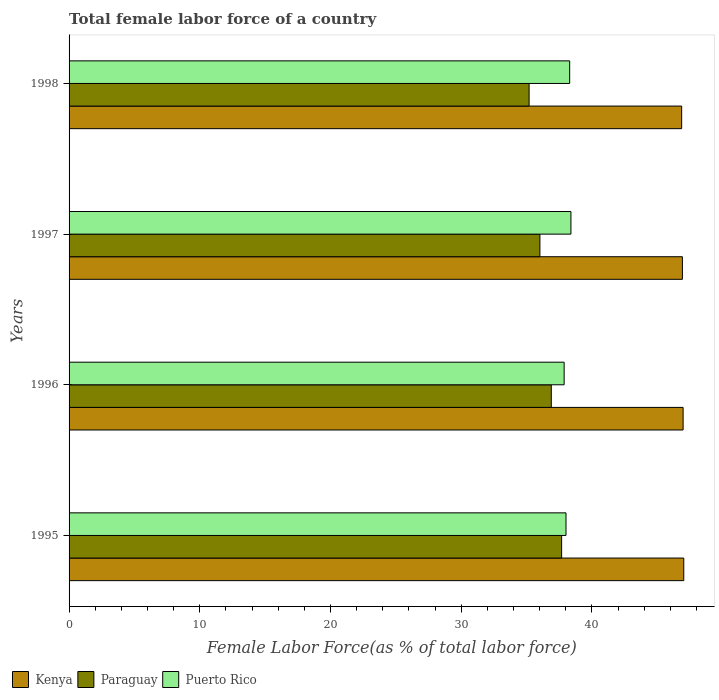Are the number of bars per tick equal to the number of legend labels?
Make the answer very short. Yes. Are the number of bars on each tick of the Y-axis equal?
Give a very brief answer. Yes. How many bars are there on the 2nd tick from the bottom?
Make the answer very short. 3. What is the percentage of female labor force in Kenya in 1996?
Your response must be concise. 46.97. Across all years, what is the maximum percentage of female labor force in Paraguay?
Ensure brevity in your answer.  37.68. Across all years, what is the minimum percentage of female labor force in Paraguay?
Your response must be concise. 35.19. In which year was the percentage of female labor force in Paraguay minimum?
Your answer should be compact. 1998. What is the total percentage of female labor force in Kenya in the graph?
Give a very brief answer. 187.78. What is the difference between the percentage of female labor force in Puerto Rico in 1995 and that in 1998?
Keep it short and to the point. -0.28. What is the difference between the percentage of female labor force in Kenya in 1996 and the percentage of female labor force in Paraguay in 1995?
Ensure brevity in your answer.  9.29. What is the average percentage of female labor force in Puerto Rico per year?
Offer a terse response. 38.14. In the year 1996, what is the difference between the percentage of female labor force in Kenya and percentage of female labor force in Paraguay?
Provide a short and direct response. 10.08. What is the ratio of the percentage of female labor force in Kenya in 1996 to that in 1998?
Make the answer very short. 1. Is the percentage of female labor force in Paraguay in 1995 less than that in 1996?
Ensure brevity in your answer.  No. What is the difference between the highest and the second highest percentage of female labor force in Paraguay?
Offer a terse response. 0.79. What is the difference between the highest and the lowest percentage of female labor force in Kenya?
Offer a terse response. 0.16. In how many years, is the percentage of female labor force in Paraguay greater than the average percentage of female labor force in Paraguay taken over all years?
Provide a short and direct response. 2. Is the sum of the percentage of female labor force in Kenya in 1995 and 1998 greater than the maximum percentage of female labor force in Paraguay across all years?
Make the answer very short. Yes. What does the 3rd bar from the top in 1997 represents?
Your answer should be compact. Kenya. What does the 2nd bar from the bottom in 1998 represents?
Keep it short and to the point. Paraguay. Are all the bars in the graph horizontal?
Provide a short and direct response. Yes. What is the difference between two consecutive major ticks on the X-axis?
Provide a short and direct response. 10. Does the graph contain any zero values?
Your response must be concise. No. Does the graph contain grids?
Provide a succinct answer. No. How many legend labels are there?
Make the answer very short. 3. What is the title of the graph?
Your response must be concise. Total female labor force of a country. What is the label or title of the X-axis?
Make the answer very short. Female Labor Force(as % of total labor force). What is the label or title of the Y-axis?
Your answer should be compact. Years. What is the Female Labor Force(as % of total labor force) of Kenya in 1995?
Make the answer very short. 47.02. What is the Female Labor Force(as % of total labor force) of Paraguay in 1995?
Make the answer very short. 37.68. What is the Female Labor Force(as % of total labor force) in Puerto Rico in 1995?
Give a very brief answer. 38.01. What is the Female Labor Force(as % of total labor force) of Kenya in 1996?
Your answer should be compact. 46.97. What is the Female Labor Force(as % of total labor force) of Paraguay in 1996?
Keep it short and to the point. 36.89. What is the Female Labor Force(as % of total labor force) in Puerto Rico in 1996?
Your answer should be very brief. 37.87. What is the Female Labor Force(as % of total labor force) in Kenya in 1997?
Offer a very short reply. 46.92. What is the Female Labor Force(as % of total labor force) in Paraguay in 1997?
Make the answer very short. 36.02. What is the Female Labor Force(as % of total labor force) in Puerto Rico in 1997?
Make the answer very short. 38.39. What is the Female Labor Force(as % of total labor force) in Kenya in 1998?
Give a very brief answer. 46.86. What is the Female Labor Force(as % of total labor force) in Paraguay in 1998?
Your answer should be very brief. 35.19. What is the Female Labor Force(as % of total labor force) in Puerto Rico in 1998?
Offer a very short reply. 38.3. Across all years, what is the maximum Female Labor Force(as % of total labor force) in Kenya?
Provide a short and direct response. 47.02. Across all years, what is the maximum Female Labor Force(as % of total labor force) in Paraguay?
Provide a succinct answer. 37.68. Across all years, what is the maximum Female Labor Force(as % of total labor force) of Puerto Rico?
Your answer should be compact. 38.39. Across all years, what is the minimum Female Labor Force(as % of total labor force) of Kenya?
Give a very brief answer. 46.86. Across all years, what is the minimum Female Labor Force(as % of total labor force) in Paraguay?
Offer a terse response. 35.19. Across all years, what is the minimum Female Labor Force(as % of total labor force) in Puerto Rico?
Ensure brevity in your answer.  37.87. What is the total Female Labor Force(as % of total labor force) in Kenya in the graph?
Give a very brief answer. 187.78. What is the total Female Labor Force(as % of total labor force) of Paraguay in the graph?
Provide a short and direct response. 145.78. What is the total Female Labor Force(as % of total labor force) in Puerto Rico in the graph?
Make the answer very short. 152.57. What is the difference between the Female Labor Force(as % of total labor force) in Kenya in 1995 and that in 1996?
Your answer should be compact. 0.05. What is the difference between the Female Labor Force(as % of total labor force) in Paraguay in 1995 and that in 1996?
Keep it short and to the point. 0.79. What is the difference between the Female Labor Force(as % of total labor force) of Puerto Rico in 1995 and that in 1996?
Provide a short and direct response. 0.14. What is the difference between the Female Labor Force(as % of total labor force) of Kenya in 1995 and that in 1997?
Provide a short and direct response. 0.1. What is the difference between the Female Labor Force(as % of total labor force) in Paraguay in 1995 and that in 1997?
Your response must be concise. 1.66. What is the difference between the Female Labor Force(as % of total labor force) in Puerto Rico in 1995 and that in 1997?
Provide a succinct answer. -0.38. What is the difference between the Female Labor Force(as % of total labor force) in Kenya in 1995 and that in 1998?
Provide a succinct answer. 0.16. What is the difference between the Female Labor Force(as % of total labor force) of Paraguay in 1995 and that in 1998?
Provide a succinct answer. 2.49. What is the difference between the Female Labor Force(as % of total labor force) of Puerto Rico in 1995 and that in 1998?
Make the answer very short. -0.28. What is the difference between the Female Labor Force(as % of total labor force) of Kenya in 1996 and that in 1997?
Offer a terse response. 0.05. What is the difference between the Female Labor Force(as % of total labor force) in Paraguay in 1996 and that in 1997?
Provide a succinct answer. 0.87. What is the difference between the Female Labor Force(as % of total labor force) of Puerto Rico in 1996 and that in 1997?
Give a very brief answer. -0.52. What is the difference between the Female Labor Force(as % of total labor force) in Kenya in 1996 and that in 1998?
Offer a terse response. 0.11. What is the difference between the Female Labor Force(as % of total labor force) of Paraguay in 1996 and that in 1998?
Your answer should be very brief. 1.7. What is the difference between the Female Labor Force(as % of total labor force) of Puerto Rico in 1996 and that in 1998?
Give a very brief answer. -0.42. What is the difference between the Female Labor Force(as % of total labor force) in Kenya in 1997 and that in 1998?
Offer a very short reply. 0.06. What is the difference between the Female Labor Force(as % of total labor force) in Paraguay in 1997 and that in 1998?
Give a very brief answer. 0.83. What is the difference between the Female Labor Force(as % of total labor force) in Puerto Rico in 1997 and that in 1998?
Offer a very short reply. 0.1. What is the difference between the Female Labor Force(as % of total labor force) in Kenya in 1995 and the Female Labor Force(as % of total labor force) in Paraguay in 1996?
Make the answer very short. 10.13. What is the difference between the Female Labor Force(as % of total labor force) in Kenya in 1995 and the Female Labor Force(as % of total labor force) in Puerto Rico in 1996?
Your response must be concise. 9.15. What is the difference between the Female Labor Force(as % of total labor force) in Paraguay in 1995 and the Female Labor Force(as % of total labor force) in Puerto Rico in 1996?
Keep it short and to the point. -0.19. What is the difference between the Female Labor Force(as % of total labor force) of Kenya in 1995 and the Female Labor Force(as % of total labor force) of Paraguay in 1997?
Make the answer very short. 11. What is the difference between the Female Labor Force(as % of total labor force) in Kenya in 1995 and the Female Labor Force(as % of total labor force) in Puerto Rico in 1997?
Your response must be concise. 8.63. What is the difference between the Female Labor Force(as % of total labor force) of Paraguay in 1995 and the Female Labor Force(as % of total labor force) of Puerto Rico in 1997?
Provide a short and direct response. -0.71. What is the difference between the Female Labor Force(as % of total labor force) of Kenya in 1995 and the Female Labor Force(as % of total labor force) of Paraguay in 1998?
Offer a terse response. 11.83. What is the difference between the Female Labor Force(as % of total labor force) in Kenya in 1995 and the Female Labor Force(as % of total labor force) in Puerto Rico in 1998?
Your answer should be compact. 8.73. What is the difference between the Female Labor Force(as % of total labor force) of Paraguay in 1995 and the Female Labor Force(as % of total labor force) of Puerto Rico in 1998?
Give a very brief answer. -0.62. What is the difference between the Female Labor Force(as % of total labor force) of Kenya in 1996 and the Female Labor Force(as % of total labor force) of Paraguay in 1997?
Make the answer very short. 10.95. What is the difference between the Female Labor Force(as % of total labor force) in Kenya in 1996 and the Female Labor Force(as % of total labor force) in Puerto Rico in 1997?
Your answer should be compact. 8.58. What is the difference between the Female Labor Force(as % of total labor force) in Paraguay in 1996 and the Female Labor Force(as % of total labor force) in Puerto Rico in 1997?
Your answer should be very brief. -1.5. What is the difference between the Female Labor Force(as % of total labor force) in Kenya in 1996 and the Female Labor Force(as % of total labor force) in Paraguay in 1998?
Make the answer very short. 11.78. What is the difference between the Female Labor Force(as % of total labor force) in Kenya in 1996 and the Female Labor Force(as % of total labor force) in Puerto Rico in 1998?
Give a very brief answer. 8.68. What is the difference between the Female Labor Force(as % of total labor force) of Paraguay in 1996 and the Female Labor Force(as % of total labor force) of Puerto Rico in 1998?
Offer a terse response. -1.41. What is the difference between the Female Labor Force(as % of total labor force) of Kenya in 1997 and the Female Labor Force(as % of total labor force) of Paraguay in 1998?
Keep it short and to the point. 11.73. What is the difference between the Female Labor Force(as % of total labor force) in Kenya in 1997 and the Female Labor Force(as % of total labor force) in Puerto Rico in 1998?
Your response must be concise. 8.62. What is the difference between the Female Labor Force(as % of total labor force) in Paraguay in 1997 and the Female Labor Force(as % of total labor force) in Puerto Rico in 1998?
Provide a short and direct response. -2.28. What is the average Female Labor Force(as % of total labor force) in Kenya per year?
Make the answer very short. 46.94. What is the average Female Labor Force(as % of total labor force) of Paraguay per year?
Keep it short and to the point. 36.44. What is the average Female Labor Force(as % of total labor force) of Puerto Rico per year?
Ensure brevity in your answer.  38.14. In the year 1995, what is the difference between the Female Labor Force(as % of total labor force) in Kenya and Female Labor Force(as % of total labor force) in Paraguay?
Offer a terse response. 9.34. In the year 1995, what is the difference between the Female Labor Force(as % of total labor force) of Kenya and Female Labor Force(as % of total labor force) of Puerto Rico?
Ensure brevity in your answer.  9.01. In the year 1995, what is the difference between the Female Labor Force(as % of total labor force) in Paraguay and Female Labor Force(as % of total labor force) in Puerto Rico?
Your response must be concise. -0.33. In the year 1996, what is the difference between the Female Labor Force(as % of total labor force) of Kenya and Female Labor Force(as % of total labor force) of Paraguay?
Your response must be concise. 10.08. In the year 1996, what is the difference between the Female Labor Force(as % of total labor force) of Kenya and Female Labor Force(as % of total labor force) of Puerto Rico?
Make the answer very short. 9.1. In the year 1996, what is the difference between the Female Labor Force(as % of total labor force) of Paraguay and Female Labor Force(as % of total labor force) of Puerto Rico?
Your answer should be compact. -0.98. In the year 1997, what is the difference between the Female Labor Force(as % of total labor force) in Kenya and Female Labor Force(as % of total labor force) in Paraguay?
Ensure brevity in your answer.  10.9. In the year 1997, what is the difference between the Female Labor Force(as % of total labor force) in Kenya and Female Labor Force(as % of total labor force) in Puerto Rico?
Give a very brief answer. 8.53. In the year 1997, what is the difference between the Female Labor Force(as % of total labor force) in Paraguay and Female Labor Force(as % of total labor force) in Puerto Rico?
Ensure brevity in your answer.  -2.37. In the year 1998, what is the difference between the Female Labor Force(as % of total labor force) in Kenya and Female Labor Force(as % of total labor force) in Paraguay?
Make the answer very short. 11.67. In the year 1998, what is the difference between the Female Labor Force(as % of total labor force) of Kenya and Female Labor Force(as % of total labor force) of Puerto Rico?
Your answer should be very brief. 8.57. In the year 1998, what is the difference between the Female Labor Force(as % of total labor force) in Paraguay and Female Labor Force(as % of total labor force) in Puerto Rico?
Your answer should be very brief. -3.1. What is the ratio of the Female Labor Force(as % of total labor force) in Kenya in 1995 to that in 1996?
Provide a short and direct response. 1. What is the ratio of the Female Labor Force(as % of total labor force) in Paraguay in 1995 to that in 1996?
Make the answer very short. 1.02. What is the ratio of the Female Labor Force(as % of total labor force) in Puerto Rico in 1995 to that in 1996?
Keep it short and to the point. 1. What is the ratio of the Female Labor Force(as % of total labor force) of Paraguay in 1995 to that in 1997?
Ensure brevity in your answer.  1.05. What is the ratio of the Female Labor Force(as % of total labor force) in Puerto Rico in 1995 to that in 1997?
Give a very brief answer. 0.99. What is the ratio of the Female Labor Force(as % of total labor force) in Kenya in 1995 to that in 1998?
Provide a succinct answer. 1. What is the ratio of the Female Labor Force(as % of total labor force) of Paraguay in 1995 to that in 1998?
Your answer should be very brief. 1.07. What is the ratio of the Female Labor Force(as % of total labor force) of Puerto Rico in 1995 to that in 1998?
Provide a short and direct response. 0.99. What is the ratio of the Female Labor Force(as % of total labor force) of Kenya in 1996 to that in 1997?
Make the answer very short. 1. What is the ratio of the Female Labor Force(as % of total labor force) of Paraguay in 1996 to that in 1997?
Keep it short and to the point. 1.02. What is the ratio of the Female Labor Force(as % of total labor force) in Puerto Rico in 1996 to that in 1997?
Provide a short and direct response. 0.99. What is the ratio of the Female Labor Force(as % of total labor force) in Kenya in 1996 to that in 1998?
Provide a succinct answer. 1. What is the ratio of the Female Labor Force(as % of total labor force) in Paraguay in 1996 to that in 1998?
Your answer should be very brief. 1.05. What is the ratio of the Female Labor Force(as % of total labor force) in Puerto Rico in 1996 to that in 1998?
Your answer should be compact. 0.99. What is the ratio of the Female Labor Force(as % of total labor force) in Paraguay in 1997 to that in 1998?
Give a very brief answer. 1.02. What is the difference between the highest and the second highest Female Labor Force(as % of total labor force) of Kenya?
Offer a very short reply. 0.05. What is the difference between the highest and the second highest Female Labor Force(as % of total labor force) of Paraguay?
Give a very brief answer. 0.79. What is the difference between the highest and the second highest Female Labor Force(as % of total labor force) of Puerto Rico?
Offer a very short reply. 0.1. What is the difference between the highest and the lowest Female Labor Force(as % of total labor force) in Kenya?
Keep it short and to the point. 0.16. What is the difference between the highest and the lowest Female Labor Force(as % of total labor force) of Paraguay?
Your answer should be compact. 2.49. What is the difference between the highest and the lowest Female Labor Force(as % of total labor force) in Puerto Rico?
Provide a short and direct response. 0.52. 